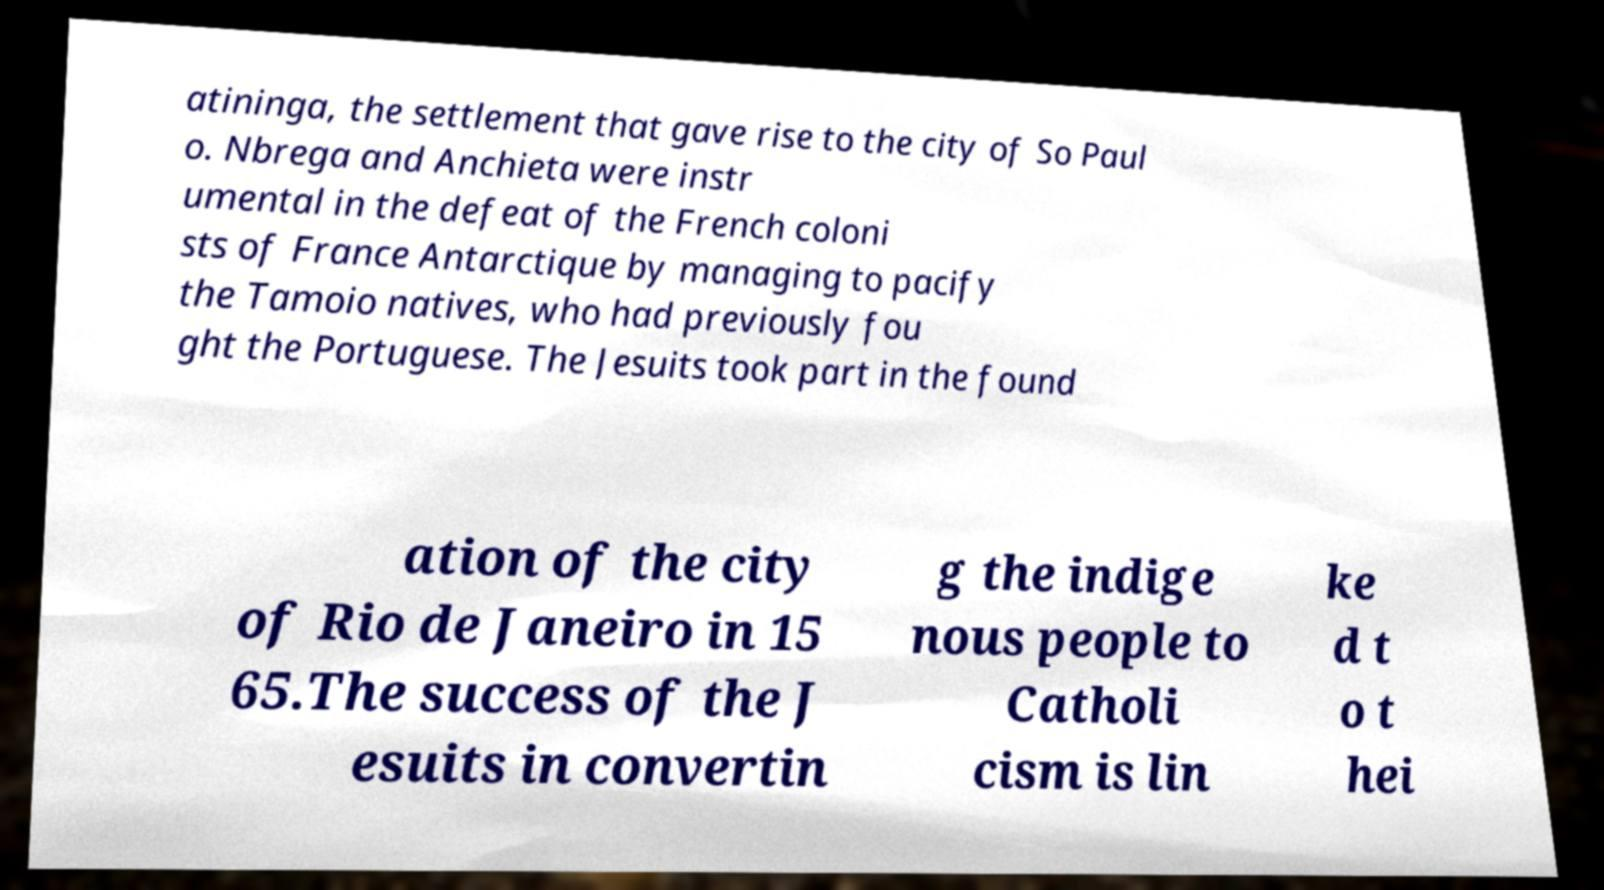Could you extract and type out the text from this image? atininga, the settlement that gave rise to the city of So Paul o. Nbrega and Anchieta were instr umental in the defeat of the French coloni sts of France Antarctique by managing to pacify the Tamoio natives, who had previously fou ght the Portuguese. The Jesuits took part in the found ation of the city of Rio de Janeiro in 15 65.The success of the J esuits in convertin g the indige nous people to Catholi cism is lin ke d t o t hei 